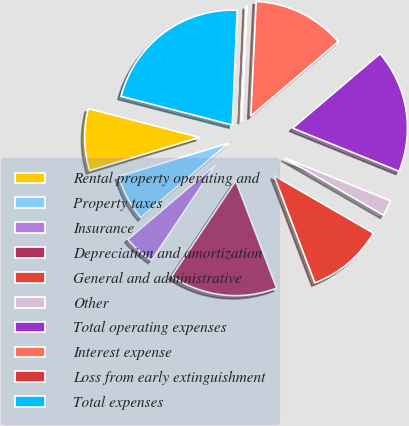Convert chart to OTSL. <chart><loc_0><loc_0><loc_500><loc_500><pie_chart><fcel>Rental property operating and<fcel>Property taxes<fcel>Insurance<fcel>Depreciation and amortization<fcel>General and administrative<fcel>Other<fcel>Total operating expenses<fcel>Interest expense<fcel>Loss from early extinguishment<fcel>Total expenses<nl><fcel>8.7%<fcel>6.54%<fcel>4.38%<fcel>15.19%<fcel>10.86%<fcel>2.22%<fcel>17.35%<fcel>13.03%<fcel>0.06%<fcel>21.67%<nl></chart> 